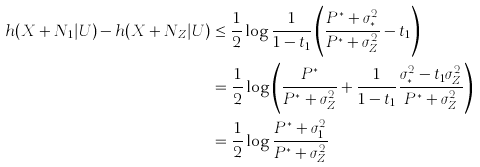Convert formula to latex. <formula><loc_0><loc_0><loc_500><loc_500>h ( X + N _ { 1 } | U ) - h ( X + N _ { Z } | U ) & \leq \frac { 1 } { 2 } \log \frac { 1 } { 1 - t _ { 1 } } \left ( \frac { P ^ { * } + \sigma _ { * } ^ { 2 } } { P ^ { * } + \sigma _ { Z } ^ { 2 } } - t _ { 1 } \right ) \\ & = \frac { 1 } { 2 } \log \left ( \frac { P ^ { * } } { P ^ { * } + \sigma _ { Z } ^ { 2 } } + \frac { 1 } { 1 - t _ { 1 } } \frac { \sigma _ { * } ^ { 2 } - t _ { 1 } \sigma _ { Z } ^ { 2 } } { P ^ { * } + \sigma _ { Z } ^ { 2 } } \right ) \\ & = \frac { 1 } { 2 } \log \frac { P ^ { * } + \sigma _ { 1 } ^ { 2 } } { P ^ { * } + \sigma _ { Z } ^ { 2 } }</formula> 